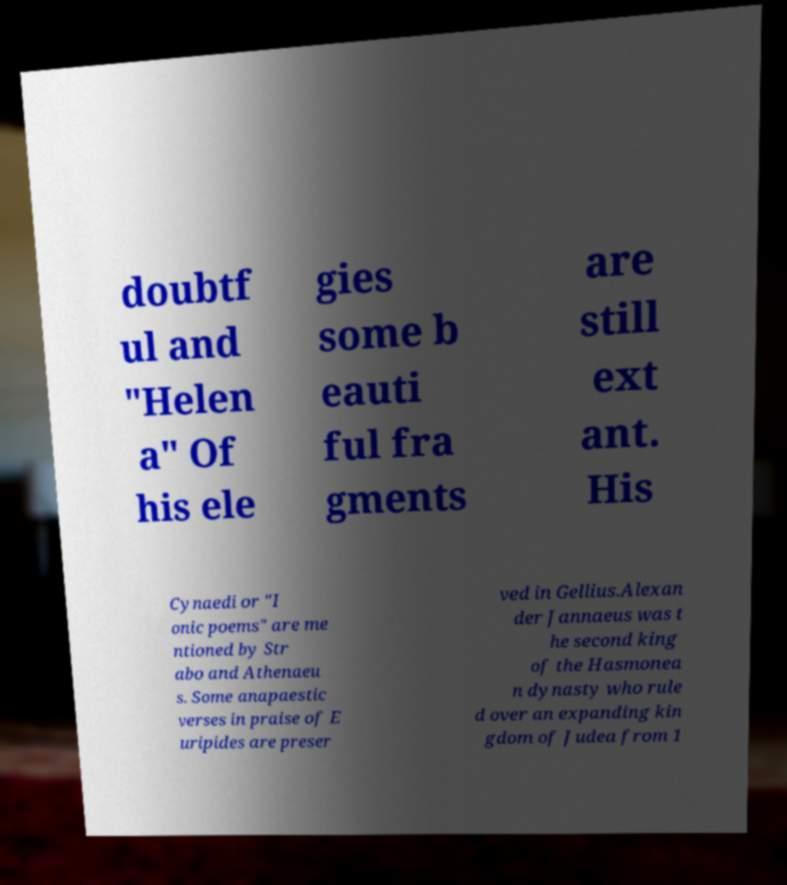Can you accurately transcribe the text from the provided image for me? doubtf ul and "Helen a" Of his ele gies some b eauti ful fra gments are still ext ant. His Cynaedi or "I onic poems" are me ntioned by Str abo and Athenaeu s. Some anapaestic verses in praise of E uripides are preser ved in Gellius.Alexan der Jannaeus was t he second king of the Hasmonea n dynasty who rule d over an expanding kin gdom of Judea from 1 